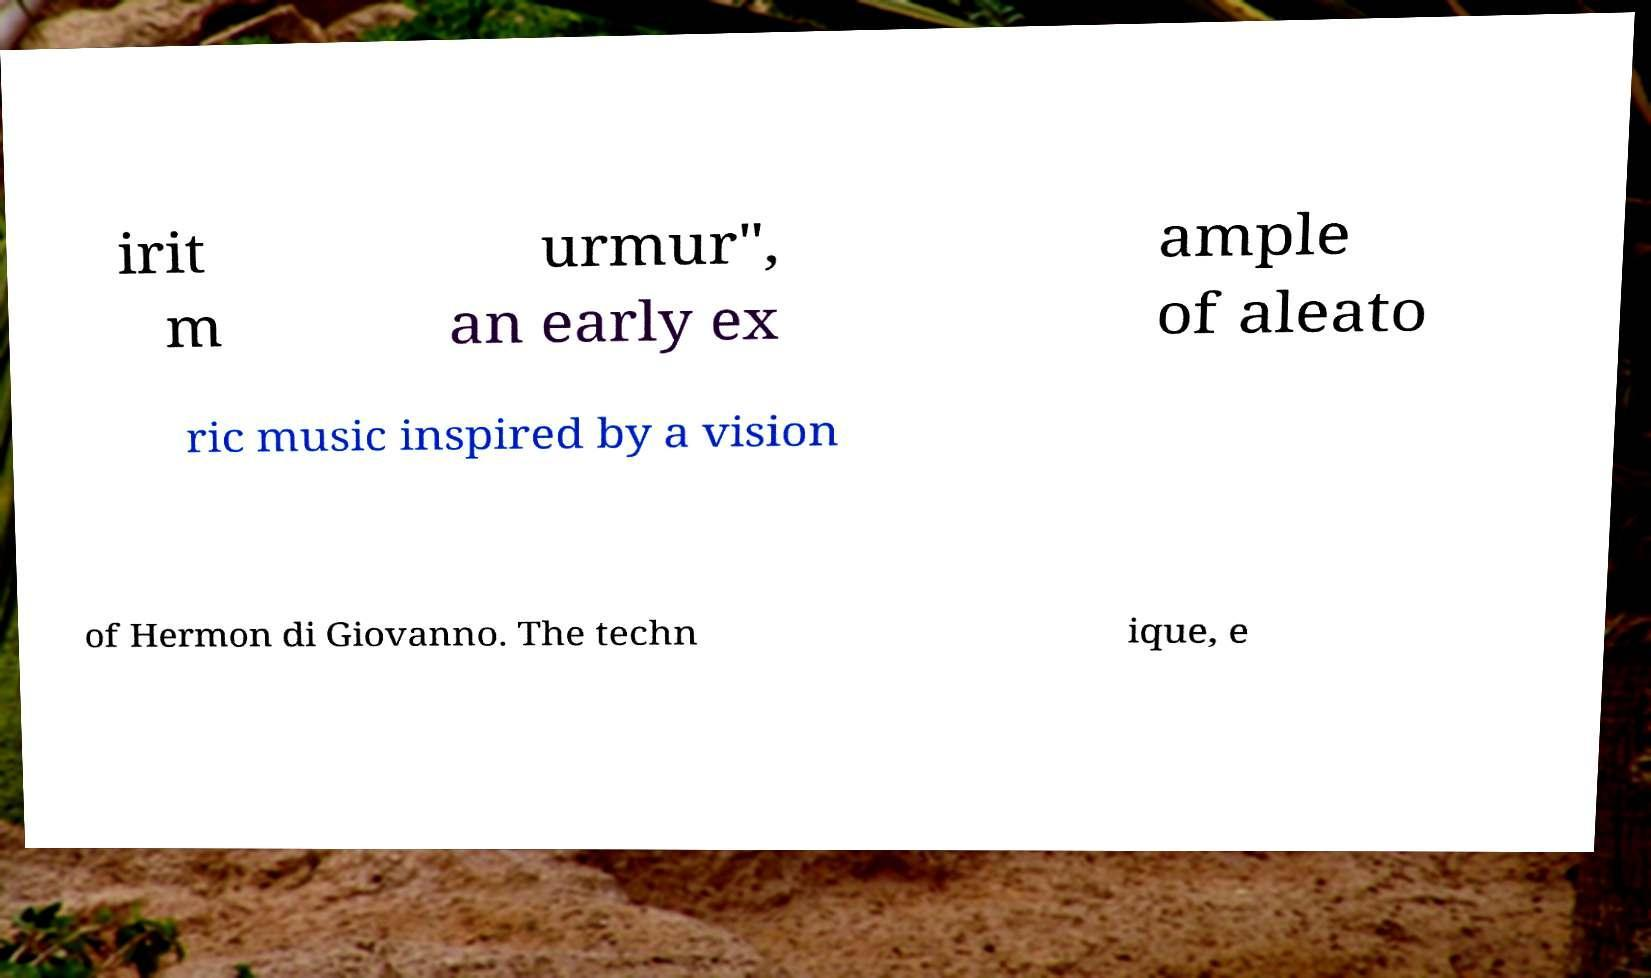I need the written content from this picture converted into text. Can you do that? irit m urmur", an early ex ample of aleato ric music inspired by a vision of Hermon di Giovanno. The techn ique, e 